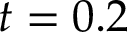Convert formula to latex. <formula><loc_0><loc_0><loc_500><loc_500>t = 0 . 2</formula> 